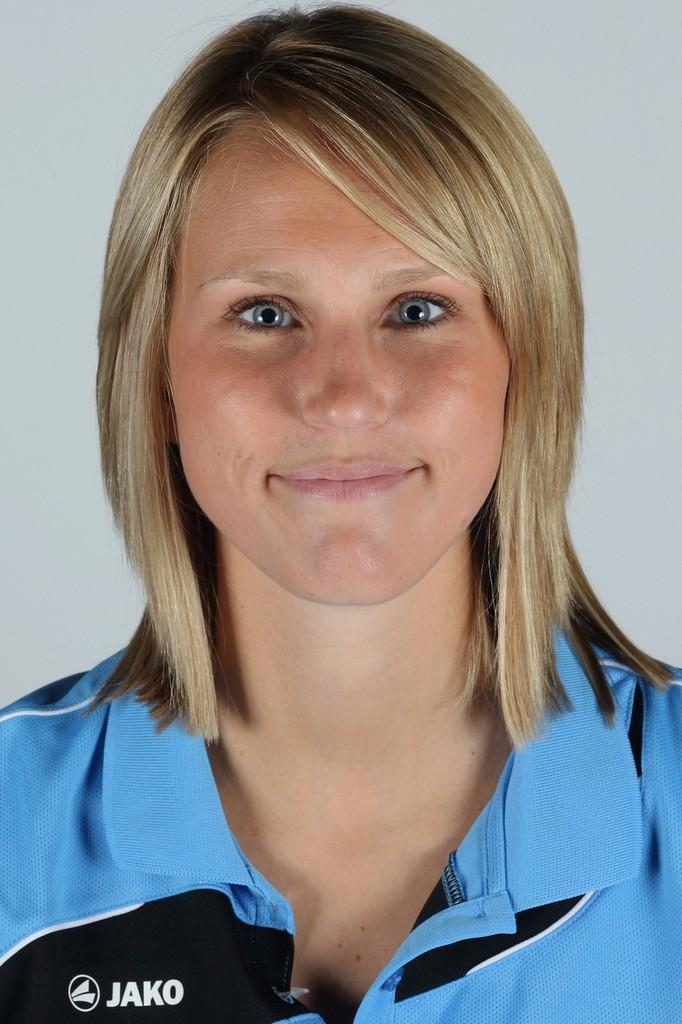<image>
Summarize the visual content of the image. A woman wearing a blue shirt with JAKO written on it smiles 